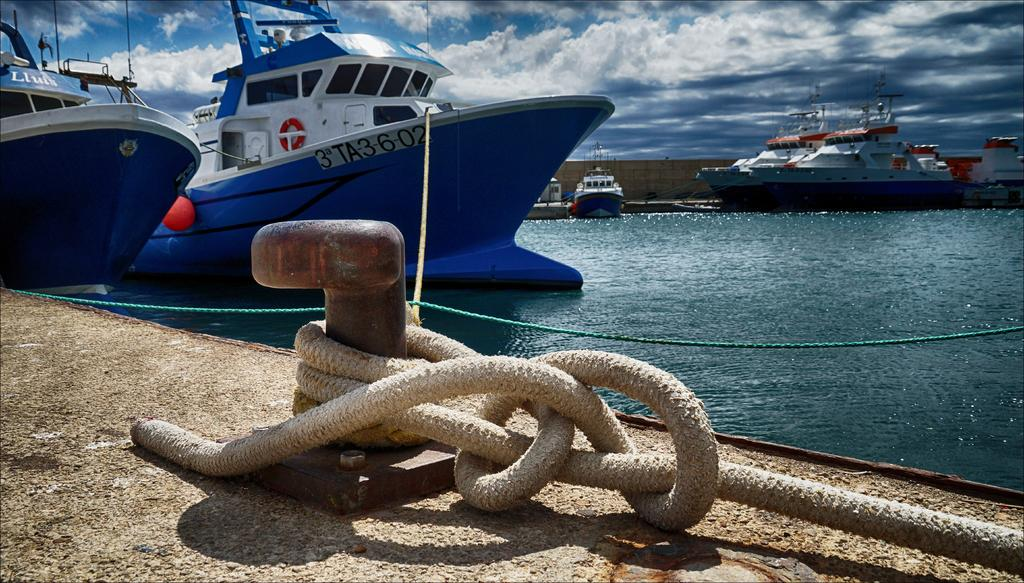What is tied to the iron stand in the image? There is a rope tied to an iron stand in the image. What can be seen on the wall in the image? Ships are depicted on the wall in the image. What part of the image is visible besides the wall? The sky is visible in the background of the image. What can be observed in the sky in the image? Clouds are present in the sky. Where is the cushion placed in the image? There is no cushion present in the image. How many pigs are visible in the image? There are no pigs depicted in the image. 